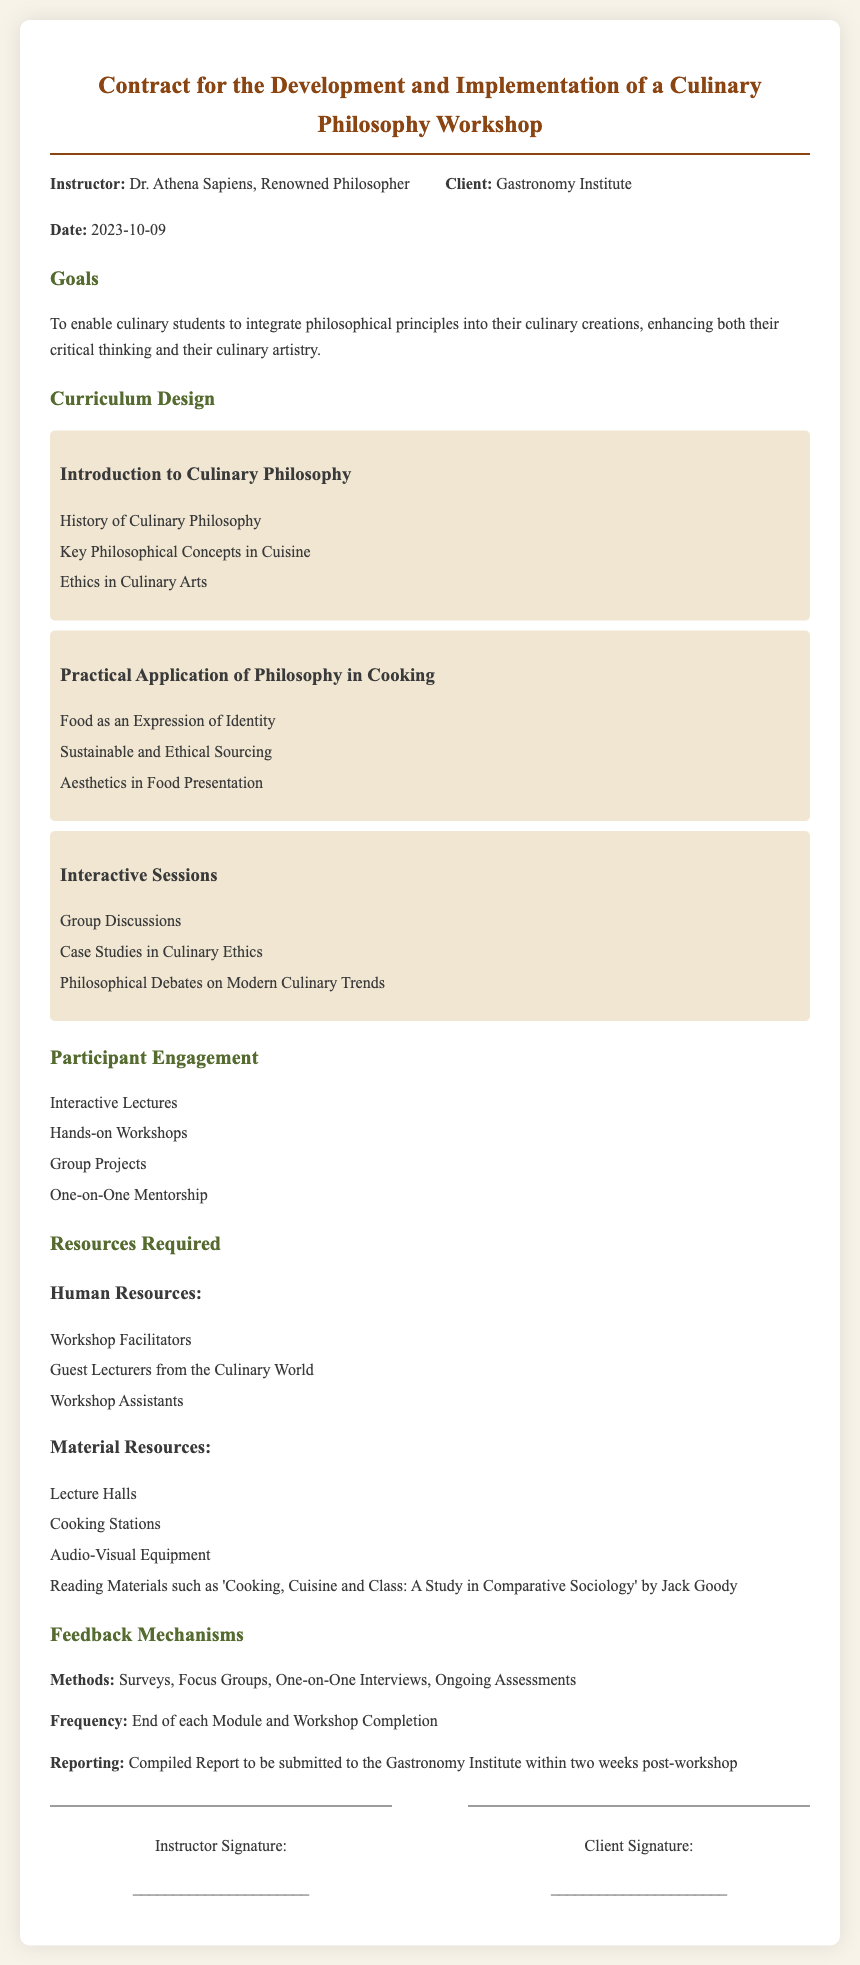what is the date of the contract? The date of the contract is specified within the document as the date it was signed.
Answer: 2023-10-09 who is the instructor of the workshop? The instructor is indicated at the beginning of the document, listing their title and expertise.
Answer: Dr. Athena Sapiens what is the main goal of the workshop? The document outlines the primary objective of the workshop according to its stated goals section.
Answer: To enable culinary students to integrate philosophical principles into their culinary creations what is one of the topics covered in the 'Introduction to Culinary Philosophy'? The topics in each module are listed in their respective sections of the document.
Answer: History of Culinary Philosophy which feedback method is mentioned in the document? The feedback mechanisms section lists various ways to gather input from participants, indicating how feedback will be collected.
Answer: Surveys how often will feedback be reported? The frequency of reporting feedback is specified in the feedback mechanisms section of the document.
Answer: End of each Module and Workshop Completion what type of resources are identified as 'Material Resources'? Human and material resources are delineated in their respective sections, specifying what is required for the workshop.
Answer: Lecture Halls who is the client for the workshop? The client is mentioned alongside the instructor at the beginning of the document, indicating the entity commissioning the workshop.
Answer: Gastronomy Institute 